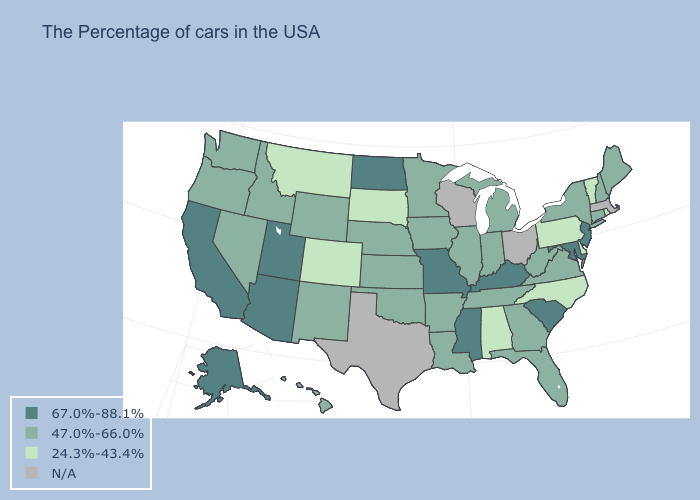Is the legend a continuous bar?
Quick response, please. No. Which states have the lowest value in the USA?
Short answer required. Rhode Island, Vermont, Delaware, Pennsylvania, North Carolina, Alabama, South Dakota, Colorado, Montana. Name the states that have a value in the range N/A?
Write a very short answer. Massachusetts, Ohio, Wisconsin, Texas. Is the legend a continuous bar?
Give a very brief answer. No. What is the value of Illinois?
Give a very brief answer. 47.0%-66.0%. Name the states that have a value in the range N/A?
Give a very brief answer. Massachusetts, Ohio, Wisconsin, Texas. Name the states that have a value in the range 67.0%-88.1%?
Answer briefly. New Jersey, Maryland, South Carolina, Kentucky, Mississippi, Missouri, North Dakota, Utah, Arizona, California, Alaska. What is the value of Rhode Island?
Write a very short answer. 24.3%-43.4%. Name the states that have a value in the range 67.0%-88.1%?
Keep it brief. New Jersey, Maryland, South Carolina, Kentucky, Mississippi, Missouri, North Dakota, Utah, Arizona, California, Alaska. Is the legend a continuous bar?
Be succinct. No. What is the highest value in the Northeast ?
Keep it brief. 67.0%-88.1%. Name the states that have a value in the range 24.3%-43.4%?
Answer briefly. Rhode Island, Vermont, Delaware, Pennsylvania, North Carolina, Alabama, South Dakota, Colorado, Montana. 